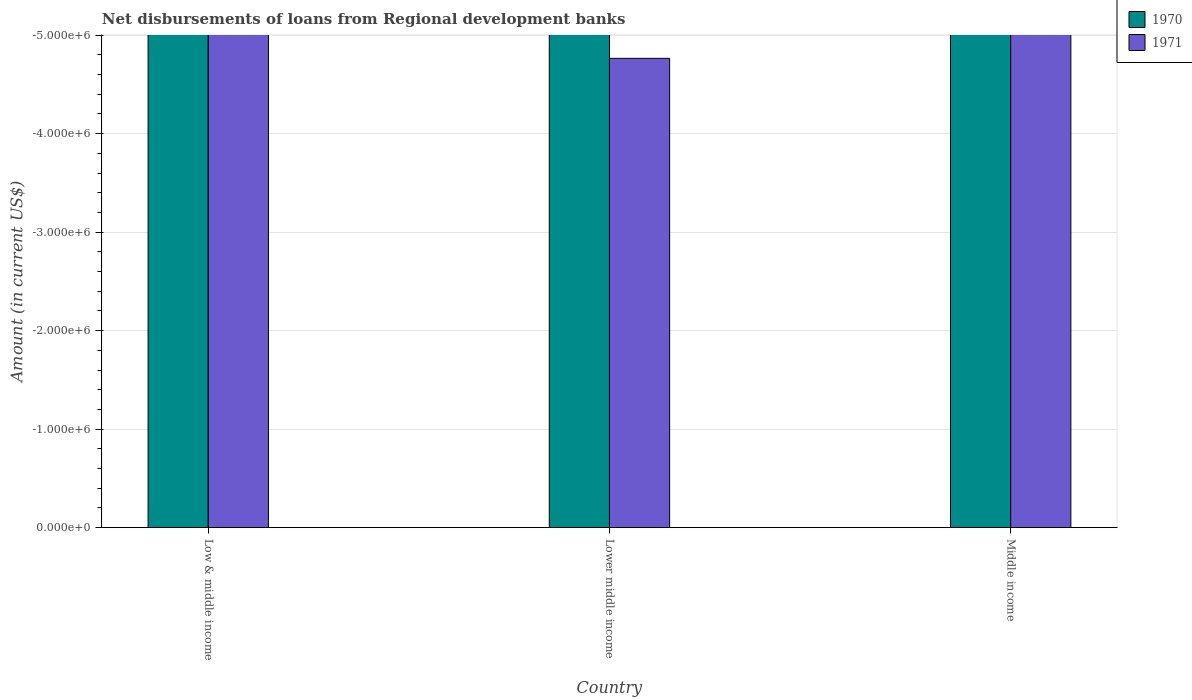Are the number of bars on each tick of the X-axis equal?
Give a very brief answer. Yes. How many bars are there on the 3rd tick from the left?
Your response must be concise. 0. How many bars are there on the 2nd tick from the right?
Give a very brief answer. 0. What is the label of the 3rd group of bars from the left?
Your answer should be very brief. Middle income. Across all countries, what is the minimum amount of disbursements of loans from regional development banks in 1970?
Your response must be concise. 0. What is the difference between the amount of disbursements of loans from regional development banks in 1971 in Lower middle income and the amount of disbursements of loans from regional development banks in 1970 in Low & middle income?
Your response must be concise. 0. In how many countries, is the amount of disbursements of loans from regional development banks in 1970 greater than the average amount of disbursements of loans from regional development banks in 1970 taken over all countries?
Your answer should be compact. 0. How many bars are there?
Your answer should be compact. 0. How many countries are there in the graph?
Ensure brevity in your answer.  3. What is the difference between two consecutive major ticks on the Y-axis?
Your answer should be compact. 1.00e+06. Does the graph contain any zero values?
Ensure brevity in your answer.  Yes. Does the graph contain grids?
Make the answer very short. Yes. Where does the legend appear in the graph?
Give a very brief answer. Top right. How many legend labels are there?
Give a very brief answer. 2. How are the legend labels stacked?
Give a very brief answer. Vertical. What is the title of the graph?
Keep it short and to the point. Net disbursements of loans from Regional development banks. Does "1972" appear as one of the legend labels in the graph?
Make the answer very short. No. What is the label or title of the X-axis?
Your answer should be compact. Country. What is the label or title of the Y-axis?
Offer a very short reply. Amount (in current US$). What is the Amount (in current US$) in 1970 in Low & middle income?
Your response must be concise. 0. What is the Amount (in current US$) of 1971 in Low & middle income?
Provide a short and direct response. 0. What is the Amount (in current US$) of 1971 in Middle income?
Offer a terse response. 0. What is the total Amount (in current US$) of 1970 in the graph?
Ensure brevity in your answer.  0. What is the total Amount (in current US$) of 1971 in the graph?
Provide a short and direct response. 0. What is the average Amount (in current US$) in 1970 per country?
Offer a terse response. 0. What is the average Amount (in current US$) of 1971 per country?
Provide a short and direct response. 0. 